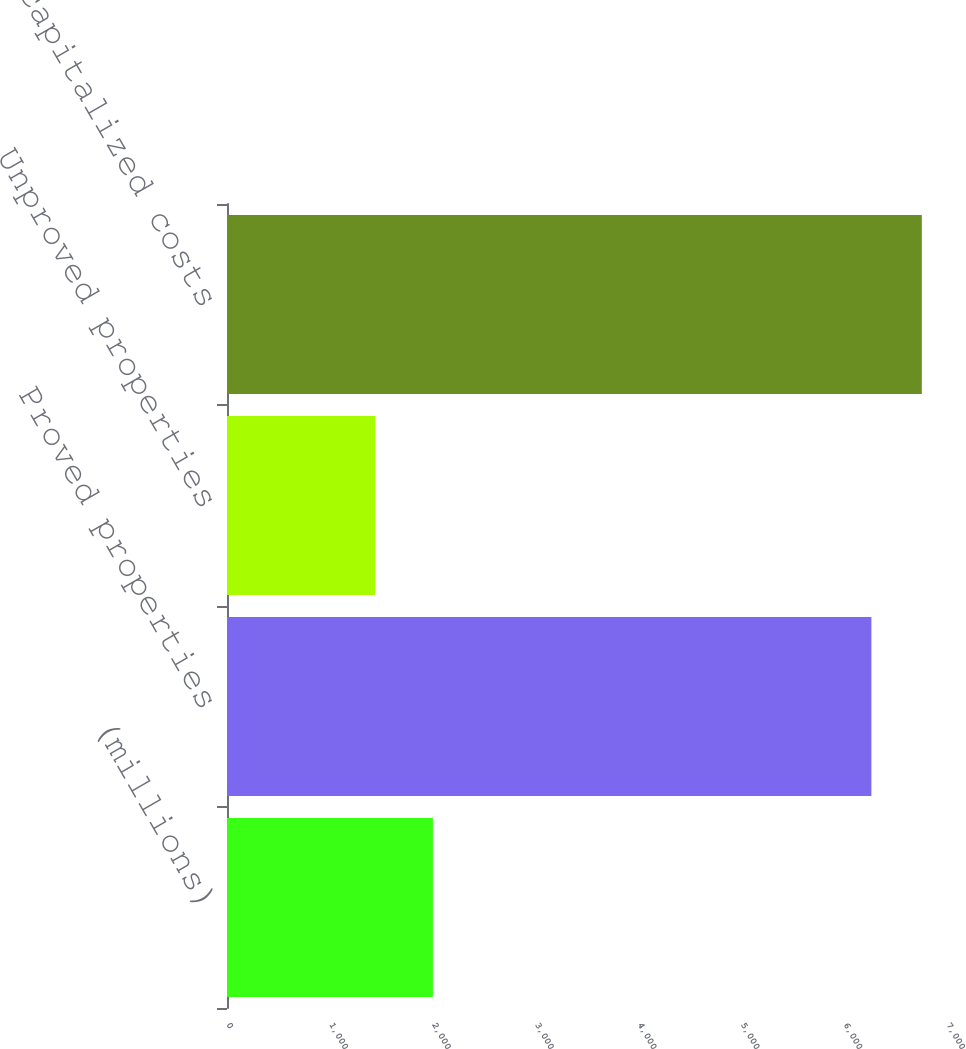Convert chart. <chart><loc_0><loc_0><loc_500><loc_500><bar_chart><fcel>(millions)<fcel>Proved properties<fcel>Unproved properties<fcel>Net capitalized costs<nl><fcel>2002<fcel>6265<fcel>1440<fcel>6755.2<nl></chart> 